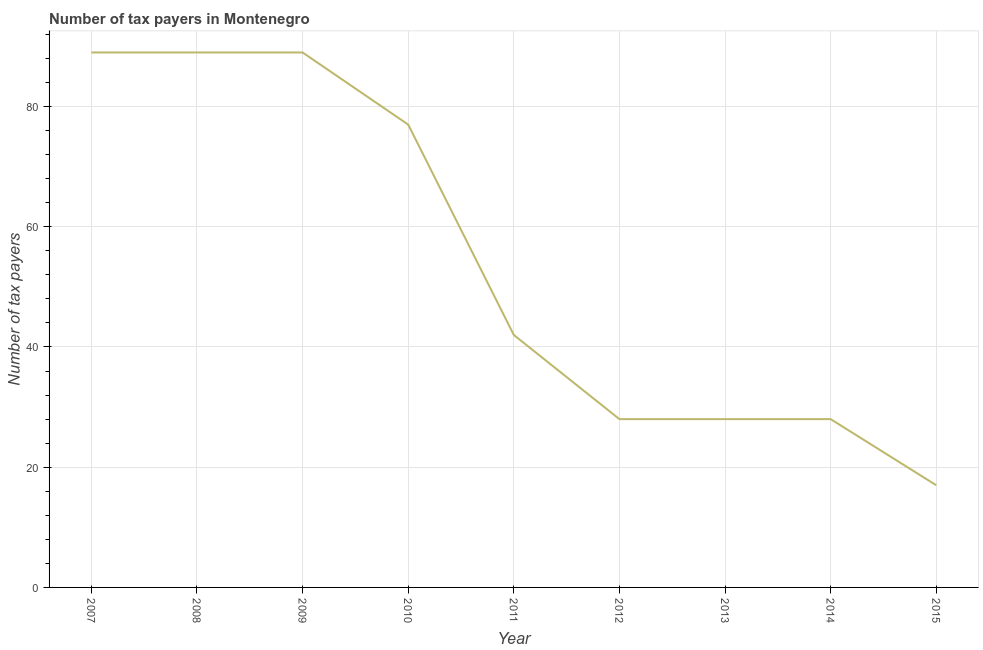What is the number of tax payers in 2009?
Your answer should be very brief. 89. Across all years, what is the maximum number of tax payers?
Your response must be concise. 89. Across all years, what is the minimum number of tax payers?
Keep it short and to the point. 17. In which year was the number of tax payers minimum?
Your answer should be very brief. 2015. What is the sum of the number of tax payers?
Provide a succinct answer. 487. What is the average number of tax payers per year?
Make the answer very short. 54.11. In how many years, is the number of tax payers greater than 44 ?
Give a very brief answer. 4. Do a majority of the years between 2012 and 2014 (inclusive) have number of tax payers greater than 40 ?
Provide a succinct answer. No. What is the ratio of the number of tax payers in 2009 to that in 2013?
Your answer should be compact. 3.18. Is the number of tax payers in 2007 less than that in 2009?
Offer a very short reply. No. Is the difference between the number of tax payers in 2011 and 2012 greater than the difference between any two years?
Make the answer very short. No. What is the difference between the highest and the second highest number of tax payers?
Offer a very short reply. 0. Is the sum of the number of tax payers in 2007 and 2011 greater than the maximum number of tax payers across all years?
Keep it short and to the point. Yes. What is the difference between the highest and the lowest number of tax payers?
Keep it short and to the point. 72. In how many years, is the number of tax payers greater than the average number of tax payers taken over all years?
Make the answer very short. 4. Does the number of tax payers monotonically increase over the years?
Provide a short and direct response. No. What is the difference between two consecutive major ticks on the Y-axis?
Your answer should be very brief. 20. Are the values on the major ticks of Y-axis written in scientific E-notation?
Keep it short and to the point. No. Does the graph contain any zero values?
Your answer should be compact. No. Does the graph contain grids?
Offer a terse response. Yes. What is the title of the graph?
Provide a short and direct response. Number of tax payers in Montenegro. What is the label or title of the Y-axis?
Your response must be concise. Number of tax payers. What is the Number of tax payers of 2007?
Provide a succinct answer. 89. What is the Number of tax payers of 2008?
Keep it short and to the point. 89. What is the Number of tax payers of 2009?
Provide a succinct answer. 89. What is the Number of tax payers of 2011?
Offer a terse response. 42. What is the Number of tax payers in 2014?
Keep it short and to the point. 28. What is the Number of tax payers of 2015?
Make the answer very short. 17. What is the difference between the Number of tax payers in 2007 and 2010?
Your answer should be very brief. 12. What is the difference between the Number of tax payers in 2007 and 2011?
Offer a terse response. 47. What is the difference between the Number of tax payers in 2007 and 2013?
Give a very brief answer. 61. What is the difference between the Number of tax payers in 2007 and 2015?
Your answer should be compact. 72. What is the difference between the Number of tax payers in 2008 and 2010?
Offer a very short reply. 12. What is the difference between the Number of tax payers in 2008 and 2012?
Ensure brevity in your answer.  61. What is the difference between the Number of tax payers in 2008 and 2014?
Offer a very short reply. 61. What is the difference between the Number of tax payers in 2010 and 2015?
Keep it short and to the point. 60. What is the difference between the Number of tax payers in 2011 and 2014?
Ensure brevity in your answer.  14. What is the difference between the Number of tax payers in 2011 and 2015?
Provide a succinct answer. 25. What is the difference between the Number of tax payers in 2012 and 2013?
Provide a succinct answer. 0. What is the difference between the Number of tax payers in 2012 and 2014?
Provide a short and direct response. 0. What is the difference between the Number of tax payers in 2012 and 2015?
Give a very brief answer. 11. What is the difference between the Number of tax payers in 2013 and 2014?
Make the answer very short. 0. What is the difference between the Number of tax payers in 2013 and 2015?
Give a very brief answer. 11. What is the difference between the Number of tax payers in 2014 and 2015?
Offer a terse response. 11. What is the ratio of the Number of tax payers in 2007 to that in 2009?
Give a very brief answer. 1. What is the ratio of the Number of tax payers in 2007 to that in 2010?
Give a very brief answer. 1.16. What is the ratio of the Number of tax payers in 2007 to that in 2011?
Offer a terse response. 2.12. What is the ratio of the Number of tax payers in 2007 to that in 2012?
Your answer should be compact. 3.18. What is the ratio of the Number of tax payers in 2007 to that in 2013?
Provide a succinct answer. 3.18. What is the ratio of the Number of tax payers in 2007 to that in 2014?
Offer a terse response. 3.18. What is the ratio of the Number of tax payers in 2007 to that in 2015?
Provide a short and direct response. 5.24. What is the ratio of the Number of tax payers in 2008 to that in 2010?
Provide a succinct answer. 1.16. What is the ratio of the Number of tax payers in 2008 to that in 2011?
Offer a very short reply. 2.12. What is the ratio of the Number of tax payers in 2008 to that in 2012?
Provide a short and direct response. 3.18. What is the ratio of the Number of tax payers in 2008 to that in 2013?
Ensure brevity in your answer.  3.18. What is the ratio of the Number of tax payers in 2008 to that in 2014?
Your response must be concise. 3.18. What is the ratio of the Number of tax payers in 2008 to that in 2015?
Make the answer very short. 5.24. What is the ratio of the Number of tax payers in 2009 to that in 2010?
Give a very brief answer. 1.16. What is the ratio of the Number of tax payers in 2009 to that in 2011?
Offer a very short reply. 2.12. What is the ratio of the Number of tax payers in 2009 to that in 2012?
Keep it short and to the point. 3.18. What is the ratio of the Number of tax payers in 2009 to that in 2013?
Ensure brevity in your answer.  3.18. What is the ratio of the Number of tax payers in 2009 to that in 2014?
Give a very brief answer. 3.18. What is the ratio of the Number of tax payers in 2009 to that in 2015?
Give a very brief answer. 5.24. What is the ratio of the Number of tax payers in 2010 to that in 2011?
Keep it short and to the point. 1.83. What is the ratio of the Number of tax payers in 2010 to that in 2012?
Offer a terse response. 2.75. What is the ratio of the Number of tax payers in 2010 to that in 2013?
Provide a succinct answer. 2.75. What is the ratio of the Number of tax payers in 2010 to that in 2014?
Keep it short and to the point. 2.75. What is the ratio of the Number of tax payers in 2010 to that in 2015?
Your answer should be very brief. 4.53. What is the ratio of the Number of tax payers in 2011 to that in 2014?
Make the answer very short. 1.5. What is the ratio of the Number of tax payers in 2011 to that in 2015?
Ensure brevity in your answer.  2.47. What is the ratio of the Number of tax payers in 2012 to that in 2014?
Keep it short and to the point. 1. What is the ratio of the Number of tax payers in 2012 to that in 2015?
Keep it short and to the point. 1.65. What is the ratio of the Number of tax payers in 2013 to that in 2014?
Offer a very short reply. 1. What is the ratio of the Number of tax payers in 2013 to that in 2015?
Keep it short and to the point. 1.65. What is the ratio of the Number of tax payers in 2014 to that in 2015?
Your answer should be compact. 1.65. 